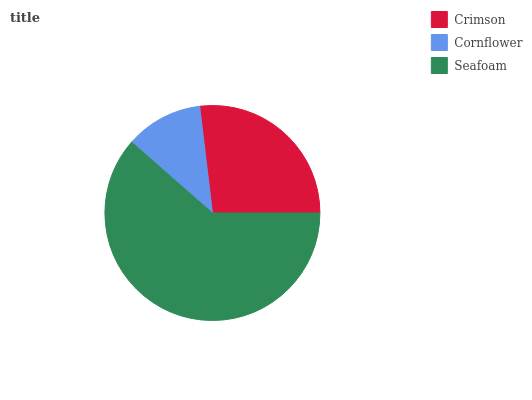Is Cornflower the minimum?
Answer yes or no. Yes. Is Seafoam the maximum?
Answer yes or no. Yes. Is Seafoam the minimum?
Answer yes or no. No. Is Cornflower the maximum?
Answer yes or no. No. Is Seafoam greater than Cornflower?
Answer yes or no. Yes. Is Cornflower less than Seafoam?
Answer yes or no. Yes. Is Cornflower greater than Seafoam?
Answer yes or no. No. Is Seafoam less than Cornflower?
Answer yes or no. No. Is Crimson the high median?
Answer yes or no. Yes. Is Crimson the low median?
Answer yes or no. Yes. Is Seafoam the high median?
Answer yes or no. No. Is Seafoam the low median?
Answer yes or no. No. 